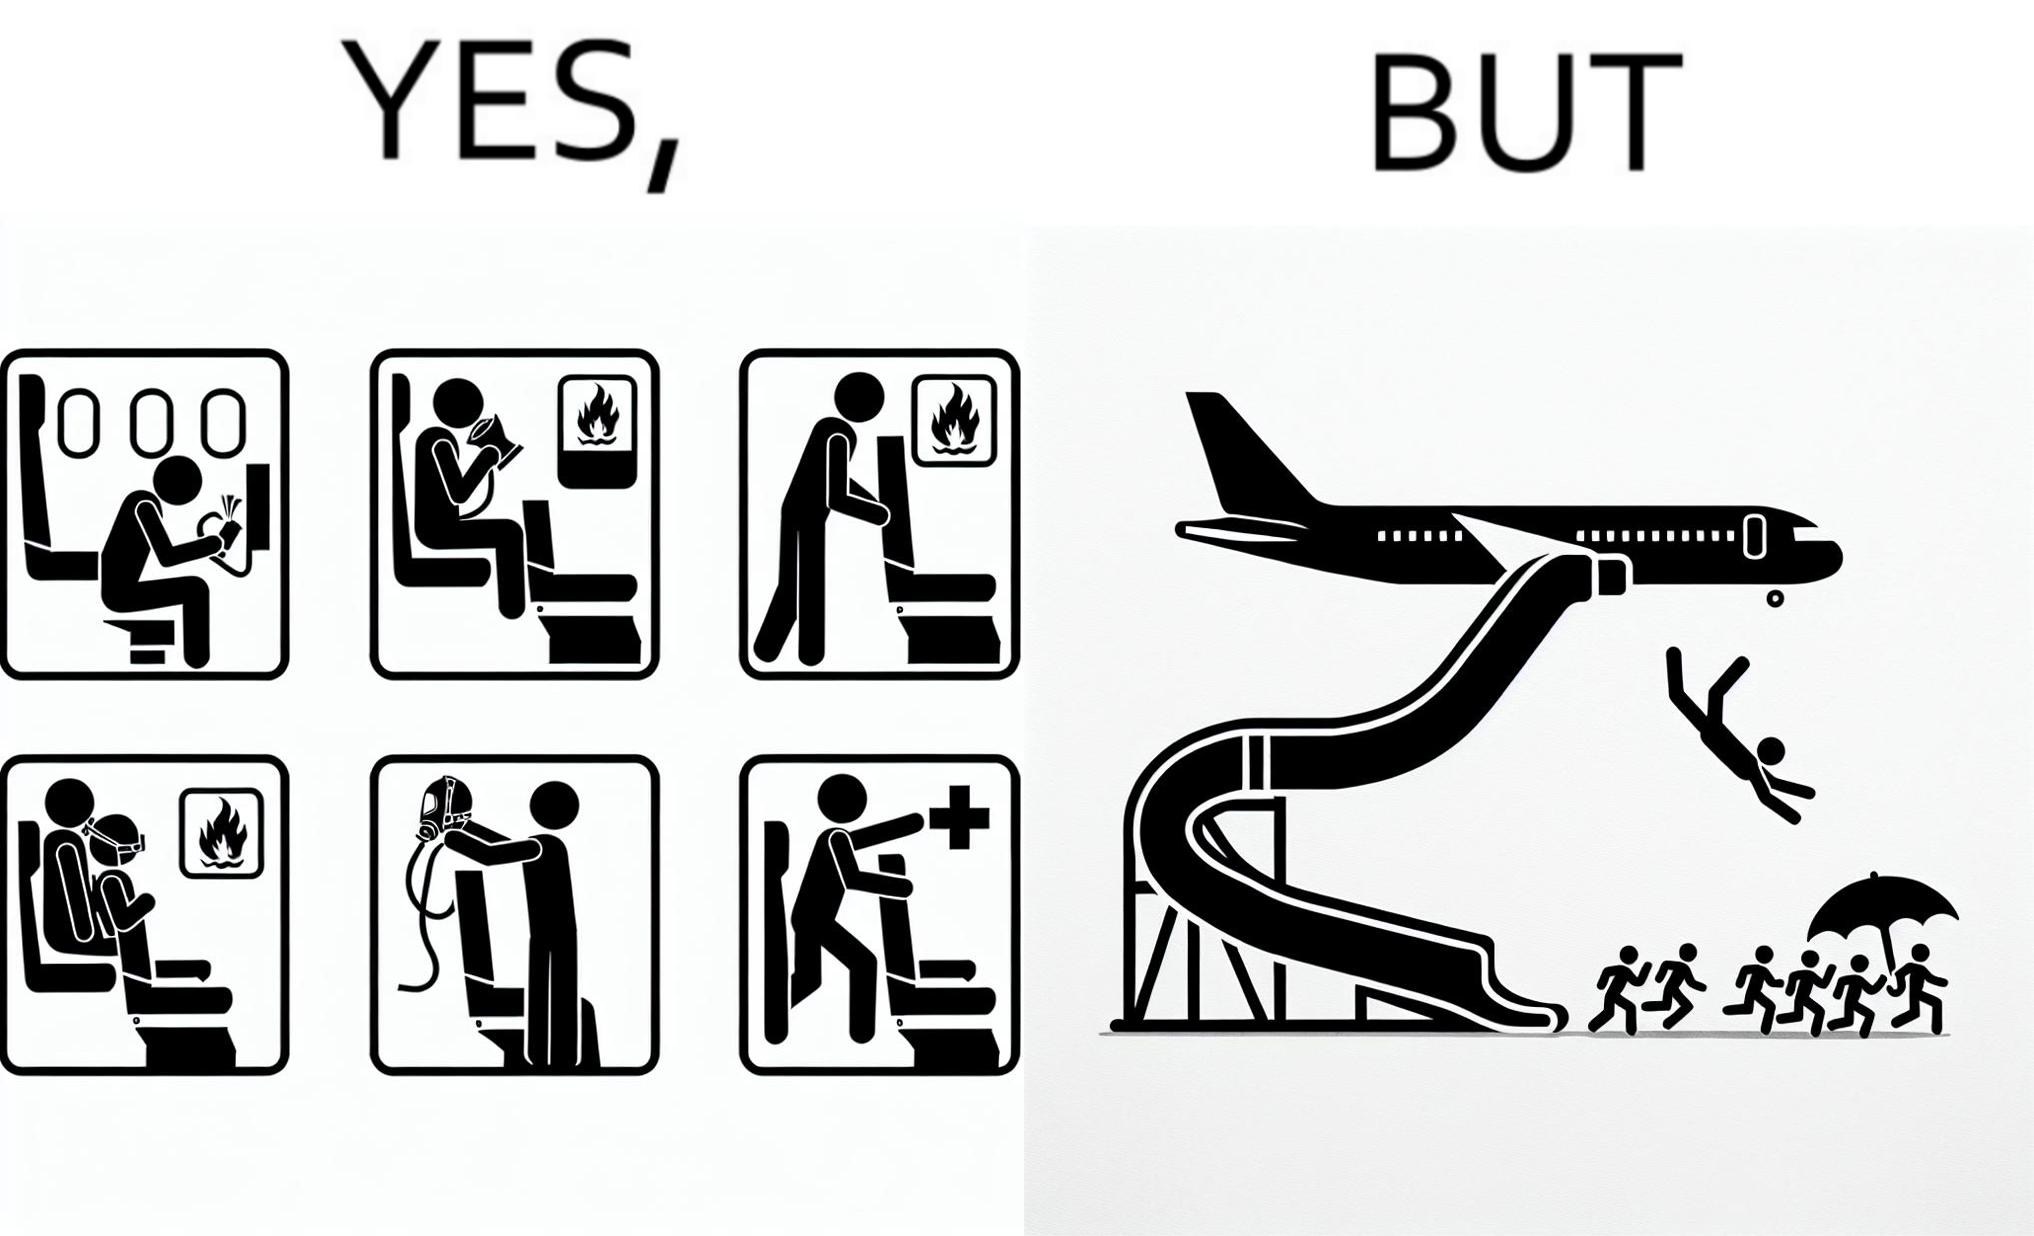Compare the left and right sides of this image. In the left part of the image: They are images of what one should do in an airplane in case of an imminent collision and fire In the right part of the image: It shows a man jumping out of an airplane in case of an emergency and using the emergency inflatable slides 